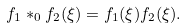<formula> <loc_0><loc_0><loc_500><loc_500>f _ { 1 } * _ { 0 } f _ { 2 } ( \xi ) = f _ { 1 } ( \xi ) f _ { 2 } ( \xi ) .</formula> 